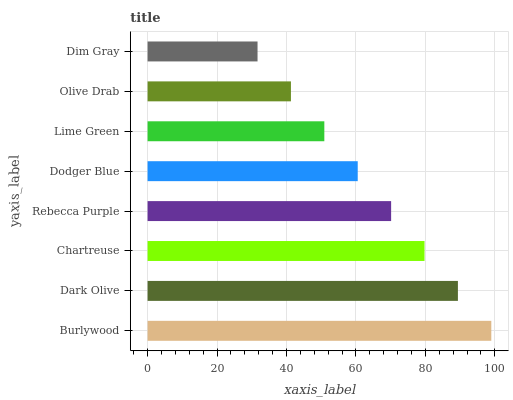Is Dim Gray the minimum?
Answer yes or no. Yes. Is Burlywood the maximum?
Answer yes or no. Yes. Is Dark Olive the minimum?
Answer yes or no. No. Is Dark Olive the maximum?
Answer yes or no. No. Is Burlywood greater than Dark Olive?
Answer yes or no. Yes. Is Dark Olive less than Burlywood?
Answer yes or no. Yes. Is Dark Olive greater than Burlywood?
Answer yes or no. No. Is Burlywood less than Dark Olive?
Answer yes or no. No. Is Rebecca Purple the high median?
Answer yes or no. Yes. Is Dodger Blue the low median?
Answer yes or no. Yes. Is Chartreuse the high median?
Answer yes or no. No. Is Lime Green the low median?
Answer yes or no. No. 